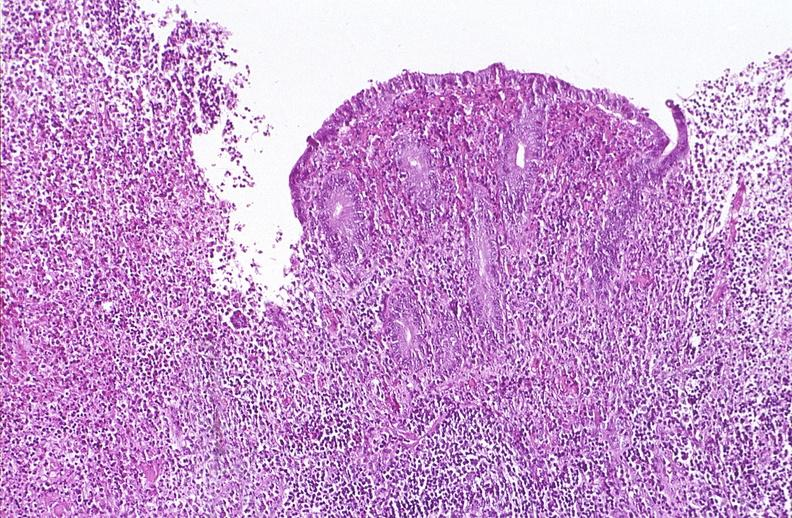does this image show appendix, acute appendicitis with ulceration of mucosa?
Answer the question using a single word or phrase. Yes 